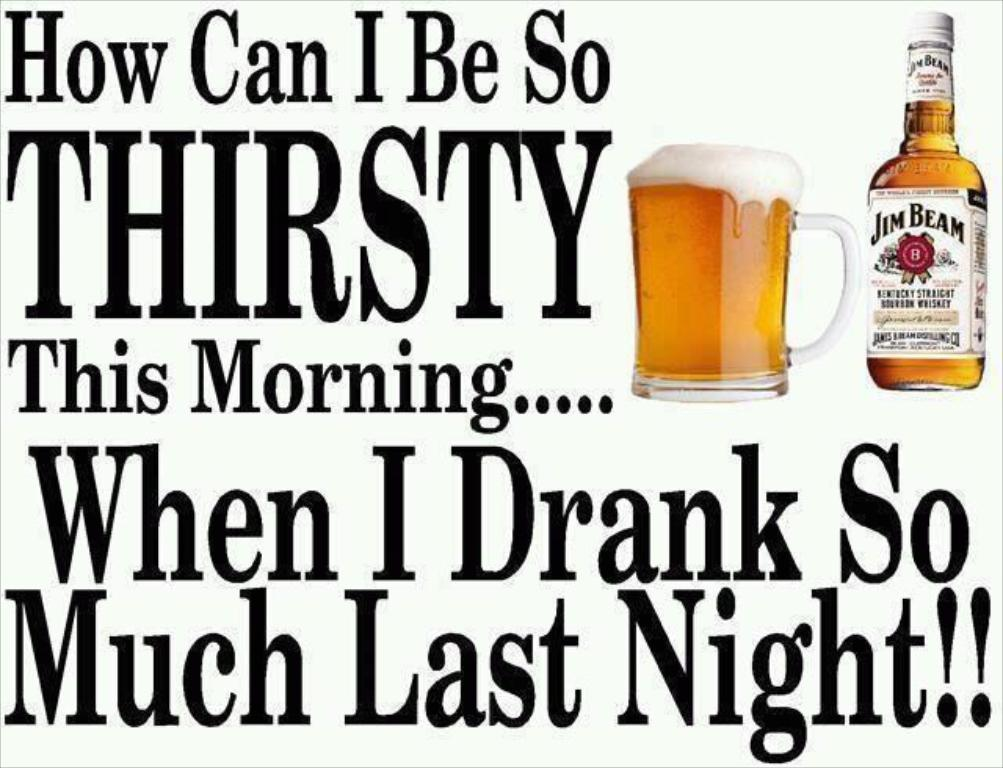<image>
Describe the image concisely. An advertisement from Jim Beam shows a pitcher of beer and a tagline. 